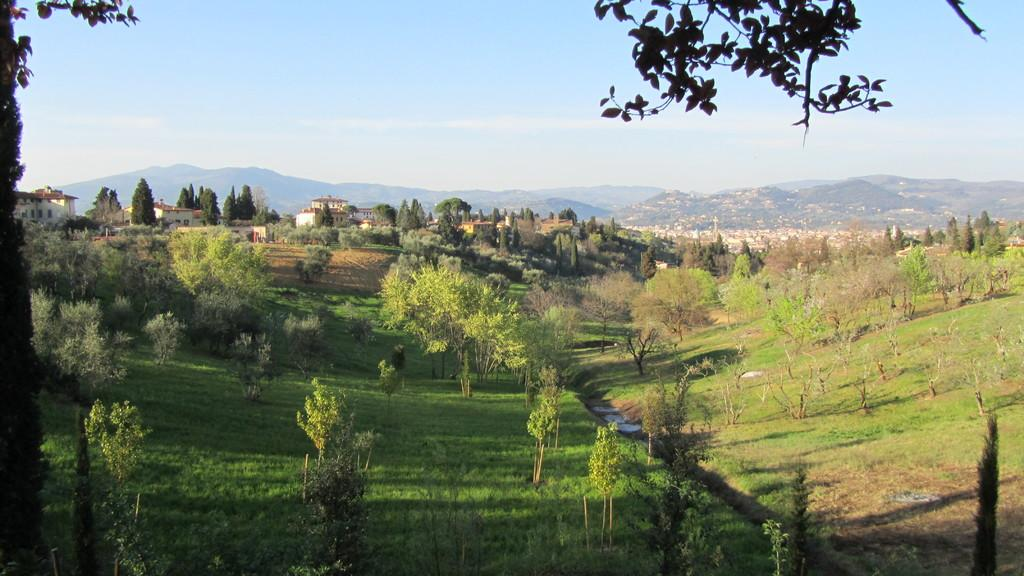What type of natural elements can be seen in the image? There are many trees in the image. What type of man-made structures are present in the image? There are buildings in the image. What geographical feature is visible in the background of the image? There is a hill in the background of the image. What is visible at the top of the image? The sky is visible at the top of the image. Can you see your dad jumping over the trees in the image? There is no person, including a dad, present in the image, and no one is jumping over the trees. 